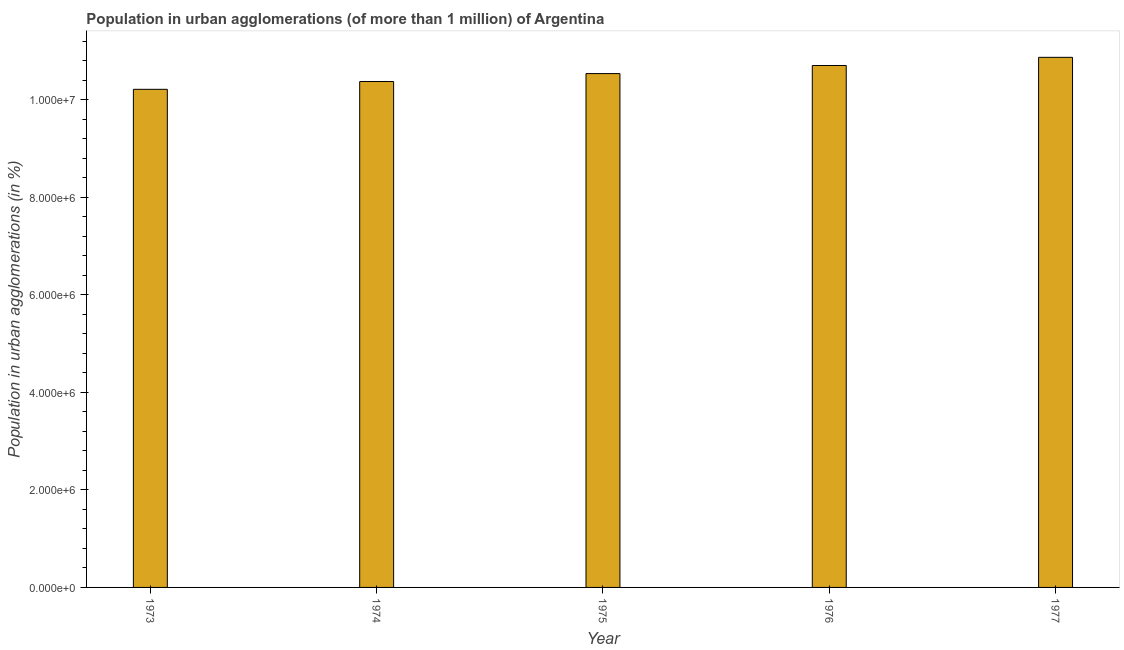Does the graph contain any zero values?
Make the answer very short. No. Does the graph contain grids?
Keep it short and to the point. No. What is the title of the graph?
Your response must be concise. Population in urban agglomerations (of more than 1 million) of Argentina. What is the label or title of the Y-axis?
Make the answer very short. Population in urban agglomerations (in %). What is the population in urban agglomerations in 1974?
Provide a short and direct response. 1.04e+07. Across all years, what is the maximum population in urban agglomerations?
Make the answer very short. 1.09e+07. Across all years, what is the minimum population in urban agglomerations?
Keep it short and to the point. 1.02e+07. In which year was the population in urban agglomerations minimum?
Keep it short and to the point. 1973. What is the sum of the population in urban agglomerations?
Provide a short and direct response. 5.27e+07. What is the difference between the population in urban agglomerations in 1973 and 1976?
Your answer should be very brief. -4.88e+05. What is the average population in urban agglomerations per year?
Your response must be concise. 1.05e+07. What is the median population in urban agglomerations?
Ensure brevity in your answer.  1.05e+07. In how many years, is the population in urban agglomerations greater than 8000000 %?
Your answer should be very brief. 5. Is the population in urban agglomerations in 1974 less than that in 1977?
Provide a short and direct response. Yes. What is the difference between the highest and the second highest population in urban agglomerations?
Provide a succinct answer. 1.68e+05. What is the difference between the highest and the lowest population in urban agglomerations?
Ensure brevity in your answer.  6.56e+05. Are the values on the major ticks of Y-axis written in scientific E-notation?
Keep it short and to the point. Yes. What is the Population in urban agglomerations (in %) in 1973?
Offer a very short reply. 1.02e+07. What is the Population in urban agglomerations (in %) in 1974?
Your answer should be very brief. 1.04e+07. What is the Population in urban agglomerations (in %) of 1975?
Your answer should be compact. 1.05e+07. What is the Population in urban agglomerations (in %) in 1976?
Your answer should be compact. 1.07e+07. What is the Population in urban agglomerations (in %) of 1977?
Give a very brief answer. 1.09e+07. What is the difference between the Population in urban agglomerations (in %) in 1973 and 1974?
Keep it short and to the point. -1.60e+05. What is the difference between the Population in urban agglomerations (in %) in 1973 and 1975?
Provide a succinct answer. -3.23e+05. What is the difference between the Population in urban agglomerations (in %) in 1973 and 1976?
Offer a terse response. -4.88e+05. What is the difference between the Population in urban agglomerations (in %) in 1973 and 1977?
Make the answer very short. -6.56e+05. What is the difference between the Population in urban agglomerations (in %) in 1974 and 1975?
Offer a very short reply. -1.63e+05. What is the difference between the Population in urban agglomerations (in %) in 1974 and 1976?
Offer a terse response. -3.28e+05. What is the difference between the Population in urban agglomerations (in %) in 1974 and 1977?
Your answer should be very brief. -4.96e+05. What is the difference between the Population in urban agglomerations (in %) in 1975 and 1976?
Your answer should be compact. -1.65e+05. What is the difference between the Population in urban agglomerations (in %) in 1975 and 1977?
Provide a short and direct response. -3.33e+05. What is the difference between the Population in urban agglomerations (in %) in 1976 and 1977?
Provide a short and direct response. -1.68e+05. What is the ratio of the Population in urban agglomerations (in %) in 1973 to that in 1975?
Your response must be concise. 0.97. What is the ratio of the Population in urban agglomerations (in %) in 1973 to that in 1976?
Provide a succinct answer. 0.95. What is the ratio of the Population in urban agglomerations (in %) in 1974 to that in 1977?
Make the answer very short. 0.95. What is the ratio of the Population in urban agglomerations (in %) in 1975 to that in 1977?
Your answer should be compact. 0.97. What is the ratio of the Population in urban agglomerations (in %) in 1976 to that in 1977?
Your answer should be compact. 0.98. 